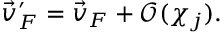Convert formula to latex. <formula><loc_0><loc_0><loc_500><loc_500>\vec { v } _ { F } ^ { \prime } = \vec { v } _ { F } + \mathcal { O } ( \chi _ { j } ) .</formula> 